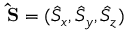<formula> <loc_0><loc_0><loc_500><loc_500>{ \hat { S } } = ( \hat { S } _ { x } , \hat { S } _ { y } , \hat { S } _ { z } )</formula> 